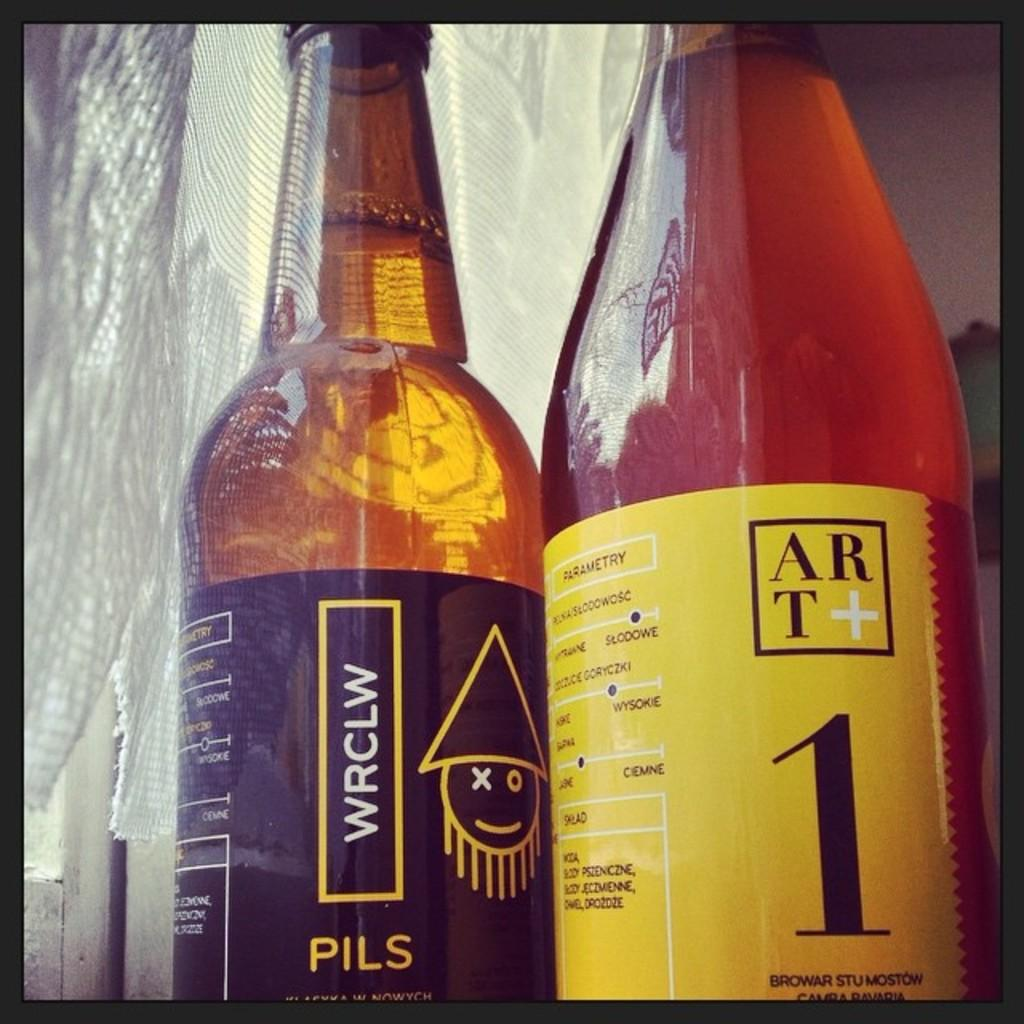<image>
Share a concise interpretation of the image provided. two glass bottles with yellow writing and the right side has a number 1 